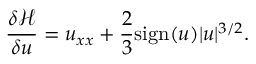Convert formula to latex. <formula><loc_0><loc_0><loc_500><loc_500>\frac { \delta \mathcal { H } } { \delta u } = u _ { x x } + \frac { 2 } { 3 } s i g n ( u ) | u | ^ { 3 / 2 } .</formula> 